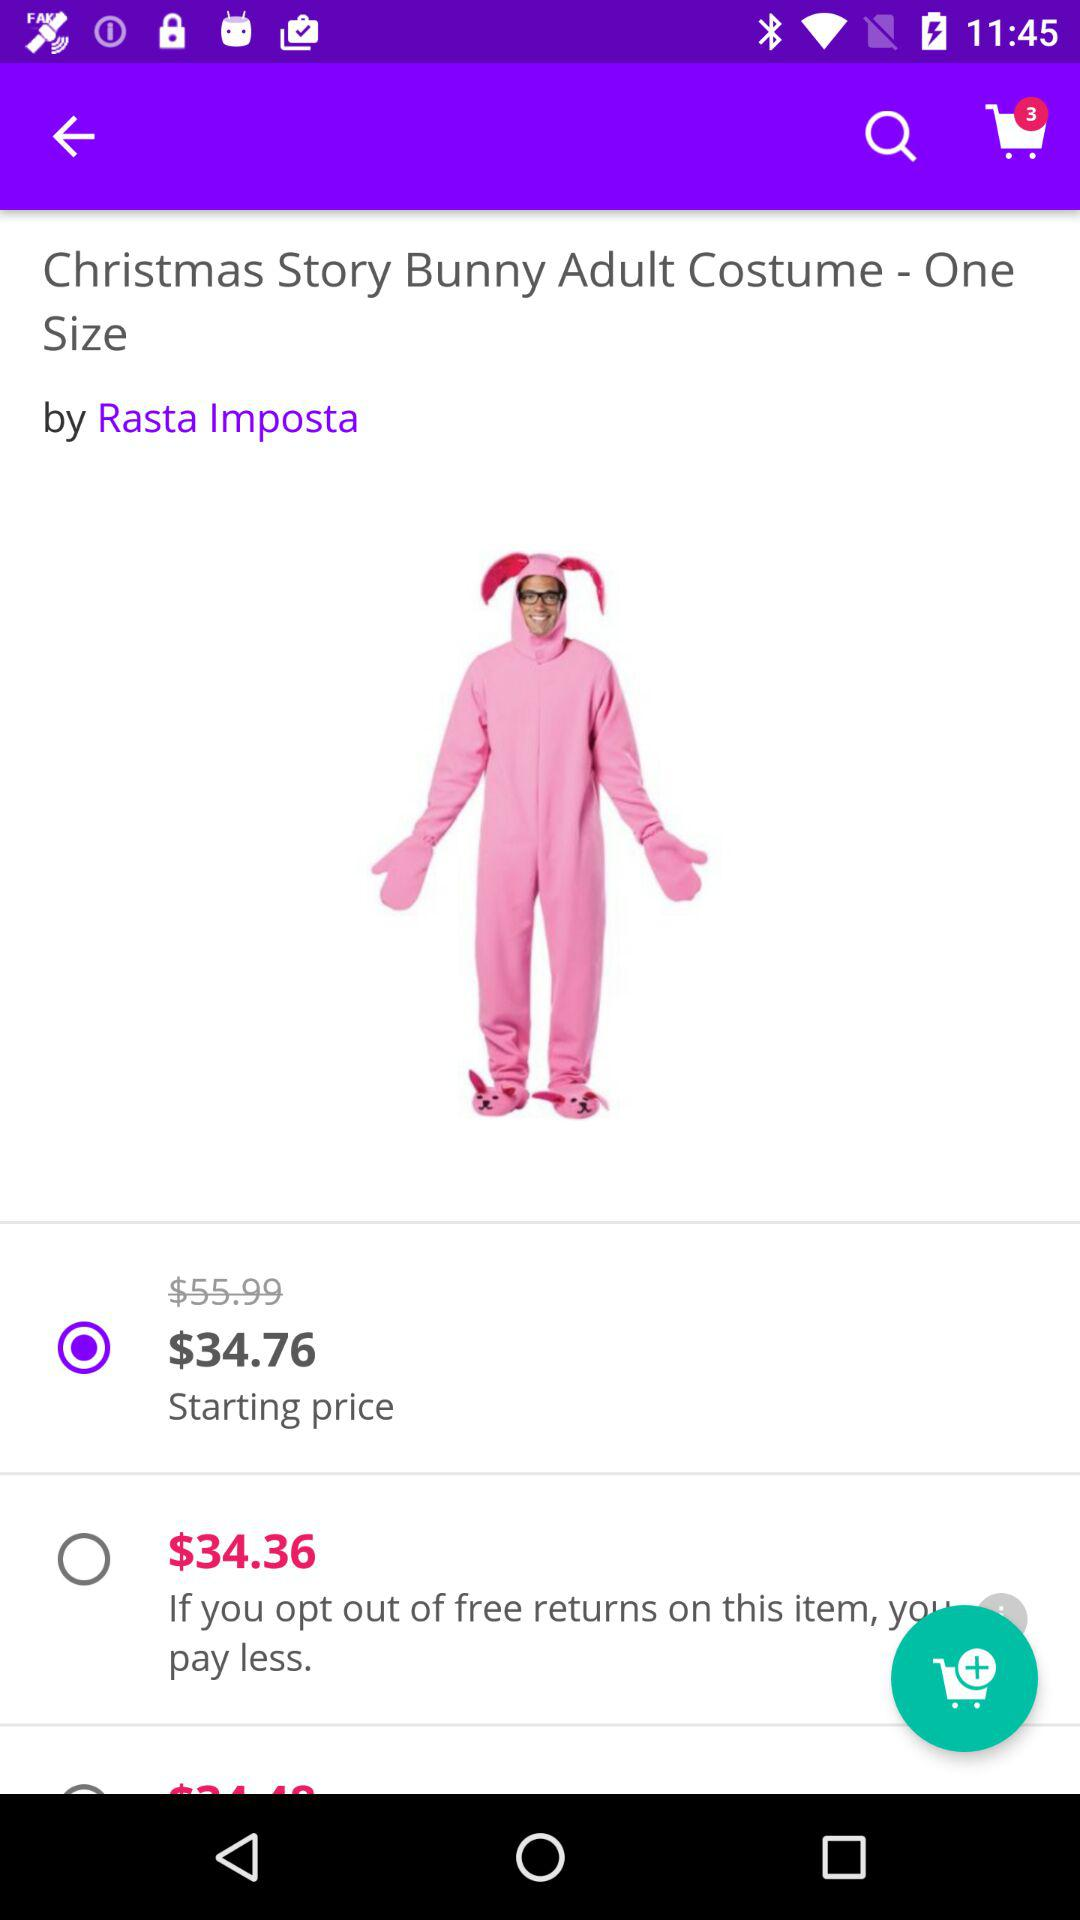What is the name of the application?
When the provided information is insufficient, respond with <no answer>. <no answer> 